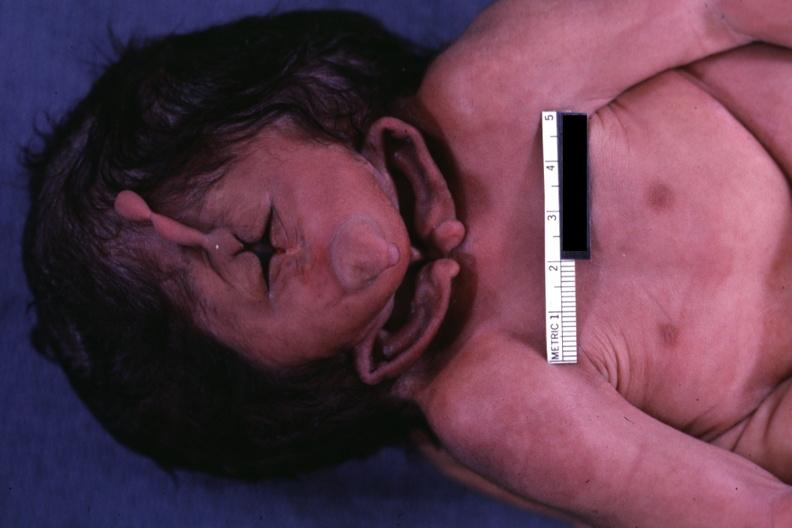does this image show close-up view of one side of head?
Answer the question using a single word or phrase. Yes 